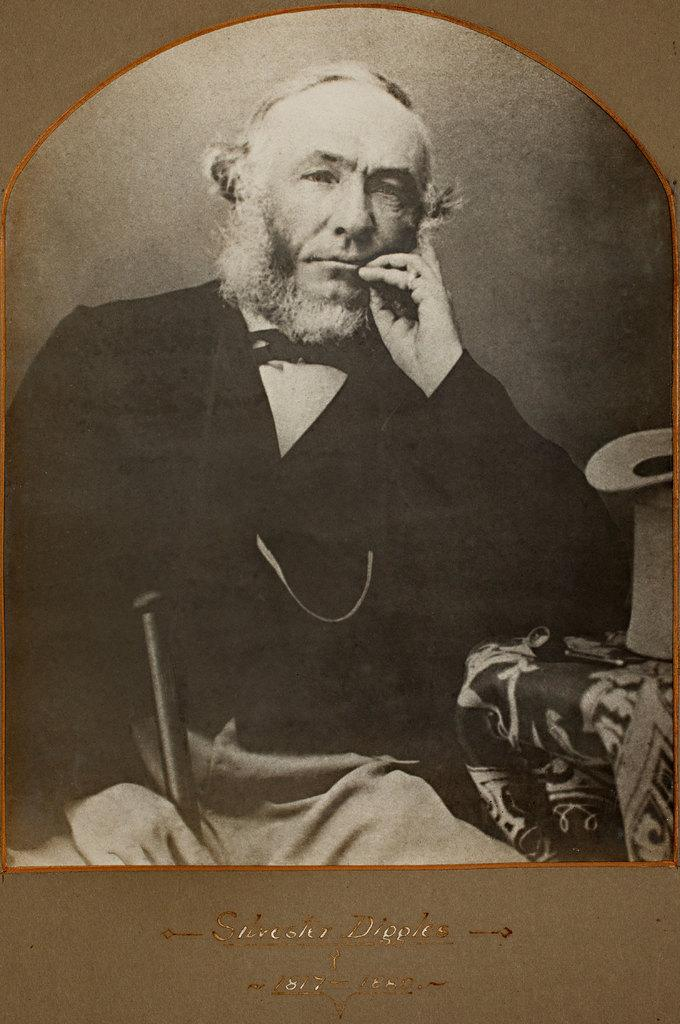What is the color scheme of the image? The image is black and white. What can be found at the bottom of the image? There is text at the bottom of the image. Who or what is in the center of the image? There is a person in the center of the image. What is the person doing in the image? The person is sitting on a couch and holding an object. What type of farm animal can be seen in the image? There are no farm animals present in the image. Can you tell me what kind of owl is perched on the person's shoulder in the image? There is no owl present in the image; the person is holding an object, but it is not an owl. 